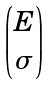Convert formula to latex. <formula><loc_0><loc_0><loc_500><loc_500>\begin{pmatrix} E \\ \sigma \end{pmatrix}</formula> 